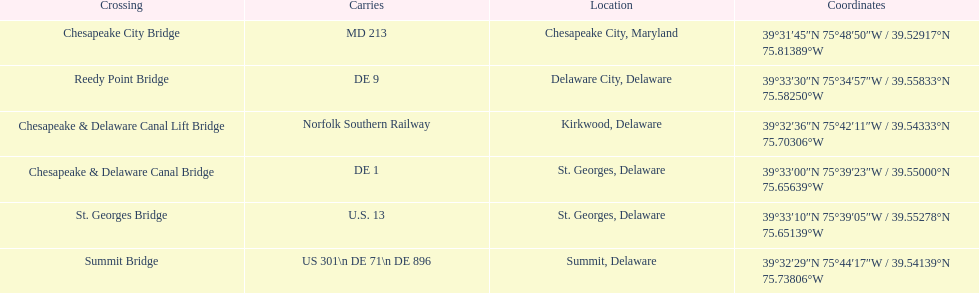Which crossing carries the most routes (e.g., de 1)? Summit Bridge. 